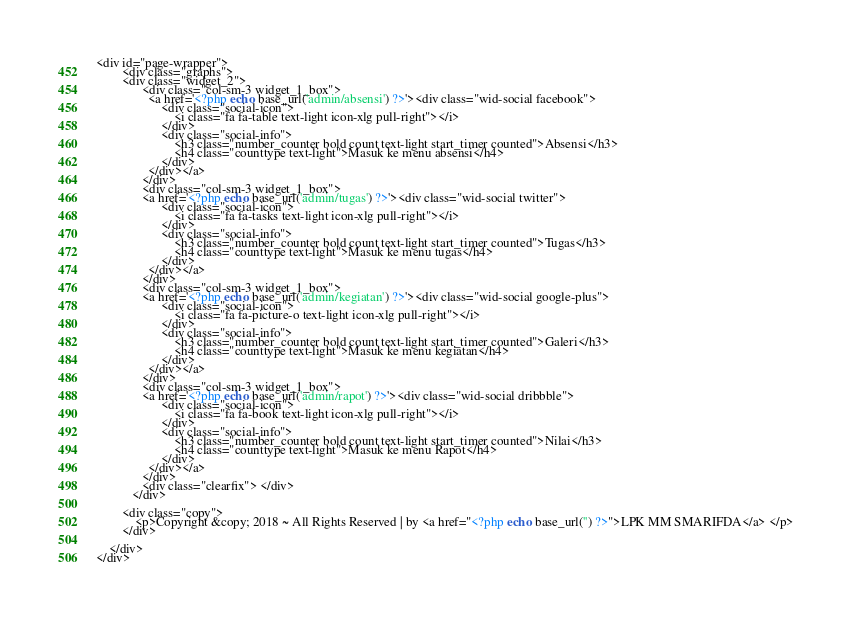Convert code to text. <code><loc_0><loc_0><loc_500><loc_500><_PHP_><div id="page-wrapper">
        <div class="graphs">
        <div class="widget_2">
		   	  <div class="col-sm-3 widget_1_box">
		   	  	<a href='<?php echo base_url('admin/absensi') ?>'><div class="wid-social facebook">
                    <div class="social-icon">
                        <i class="fa fa-table text-light icon-xlg pull-right"></i>
                    </div>
                    <div class="social-info">
                        <h3 class="number_counter bold count text-light start_timer counted">Absensi</h3>
                        <h4 class="counttype text-light">Masuk ke menu absensi</h4>
                    </div>
                </div></a>
              </div>
              <div class="col-sm-3 widget_1_box">
              <a href='<?php echo base_url('admin/tugas') ?>'><div class="wid-social twitter">
                    <div class="social-icon">
                        <i class="fa fa-tasks text-light icon-xlg pull-right"></i>
                    </div>
                    <div class="social-info">
                        <h3 class="number_counter bold count text-light start_timer counted">Tugas</h3>
                        <h4 class="counttype text-light">Masuk ke menu tugas</h4>
                    </div>
                </div></a>
			  </div>
              <div class="col-sm-3 widget_1_box">
              <a href='<?php echo base_url('admin/kegiatan') ?>'><div class="wid-social google-plus">
                    <div class="social-icon">
                        <i class="fa fa-picture-o text-light icon-xlg pull-right"></i>
                    </div>
                    <div class="social-info">
                        <h3 class="number_counter bold count text-light start_timer counted">Galeri</h3>
                        <h4 class="counttype text-light">Masuk ke menu kegiatan</h4>
                    </div>
                </div></a>
			  </div>
              <div class="col-sm-3 widget_1_box">
              <a href='<?php echo base_url('admin/rapot') ?>'><div class="wid-social dribbble">
                    <div class="social-icon">
                        <i class="fa fa-book text-light icon-xlg pull-right"></i>
                    </div>
                    <div class="social-info">
                        <h3 class="number_counter bold count text-light start_timer counted">Nilai</h3>
                        <h4 class="counttype text-light">Masuk ke menu Rapot</h4>
                    </div>
                </div></a>
			  </div>
              <div class="clearfix"> </div>
		   </div>

        <div class="copy">
            <p>Copyright &copy; 2018 ~ All Rights Reserved | by <a href="<?php echo base_url('') ?>">LPK MM SMARIFDA</a> </p>
	    </div>

    </div>
</div></code> 